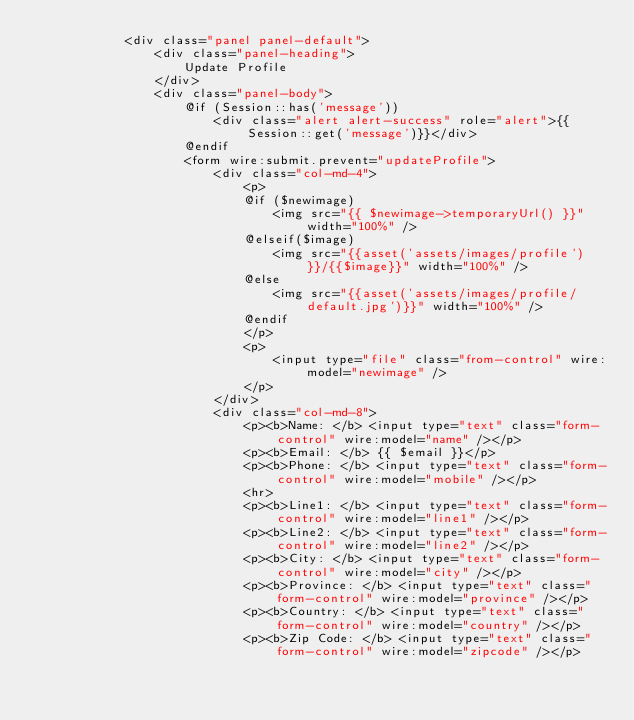Convert code to text. <code><loc_0><loc_0><loc_500><loc_500><_PHP_>            <div class="panel panel-default">
                <div class="panel-heading">
                    Update Profile
                </div>
                <div class="panel-body">
                    @if (Session::has('message'))
                        <div class="alert alert-success" role="alert">{{Session::get('message')}}</div>
                    @endif
                    <form wire:submit.prevent="updateProfile">
                        <div class="col-md-4">
                            <p>
                            @if ($newimage)
                                <img src="{{ $newimage->temporaryUrl() }}" width="100%" /> 
                            @elseif($image)
                                <img src="{{asset('assets/images/profile')}}/{{$image}}" width="100%" />
                            @else
                                <img src="{{asset('assets/images/profile/default.jpg')}}" width="100%" /> 
                            @endif
                            </p>
                            <p>
                                <input type="file" class="from-control" wire:model="newimage" />
                            </p>
                        </div>
                        <div class="col-md-8">
                            <p><b>Name: </b> <input type="text" class="form-control" wire:model="name" /></p>
                            <p><b>Email: </b> {{ $email }}</p>
                            <p><b>Phone: </b> <input type="text" class="form-control" wire:model="mobile" /></p>
                            <hr>
                            <p><b>Line1: </b> <input type="text" class="form-control" wire:model="line1" /></p>
                            <p><b>Line2: </b> <input type="text" class="form-control" wire:model="line2" /></p>
                            <p><b>City: </b> <input type="text" class="form-control" wire:model="city" /></p>
                            <p><b>Province: </b> <input type="text" class="form-control" wire:model="province" /></p>
                            <p><b>Country: </b> <input type="text" class="form-control" wire:model="country" /></p>
                            <p><b>Zip Code: </b> <input type="text" class="form-control" wire:model="zipcode" /></p></code> 